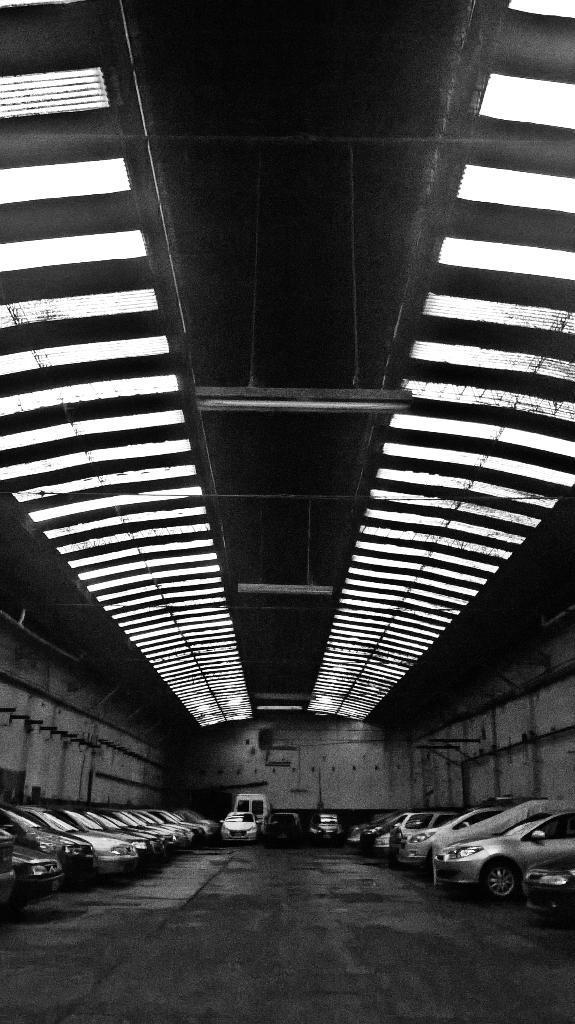How would you summarize this image in a sentence or two? In this image at the bottom there are many cars, floor. In the middle there is wall. At the top there are lights, roof and shed. 